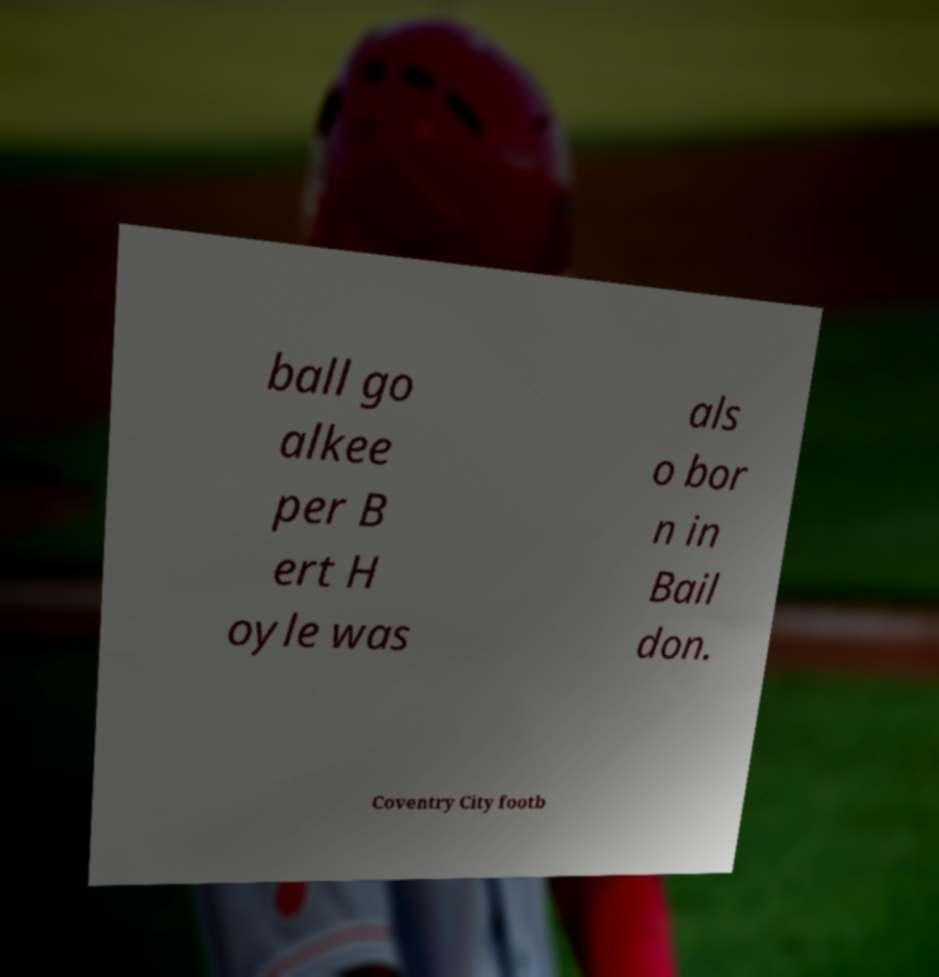Can you read and provide the text displayed in the image?This photo seems to have some interesting text. Can you extract and type it out for me? ball go alkee per B ert H oyle was als o bor n in Bail don. Coventry City footb 